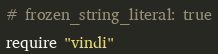Convert code to text. <code><loc_0><loc_0><loc_500><loc_500><_Ruby_># frozen_string_literal: true

require "vindi"
</code> 